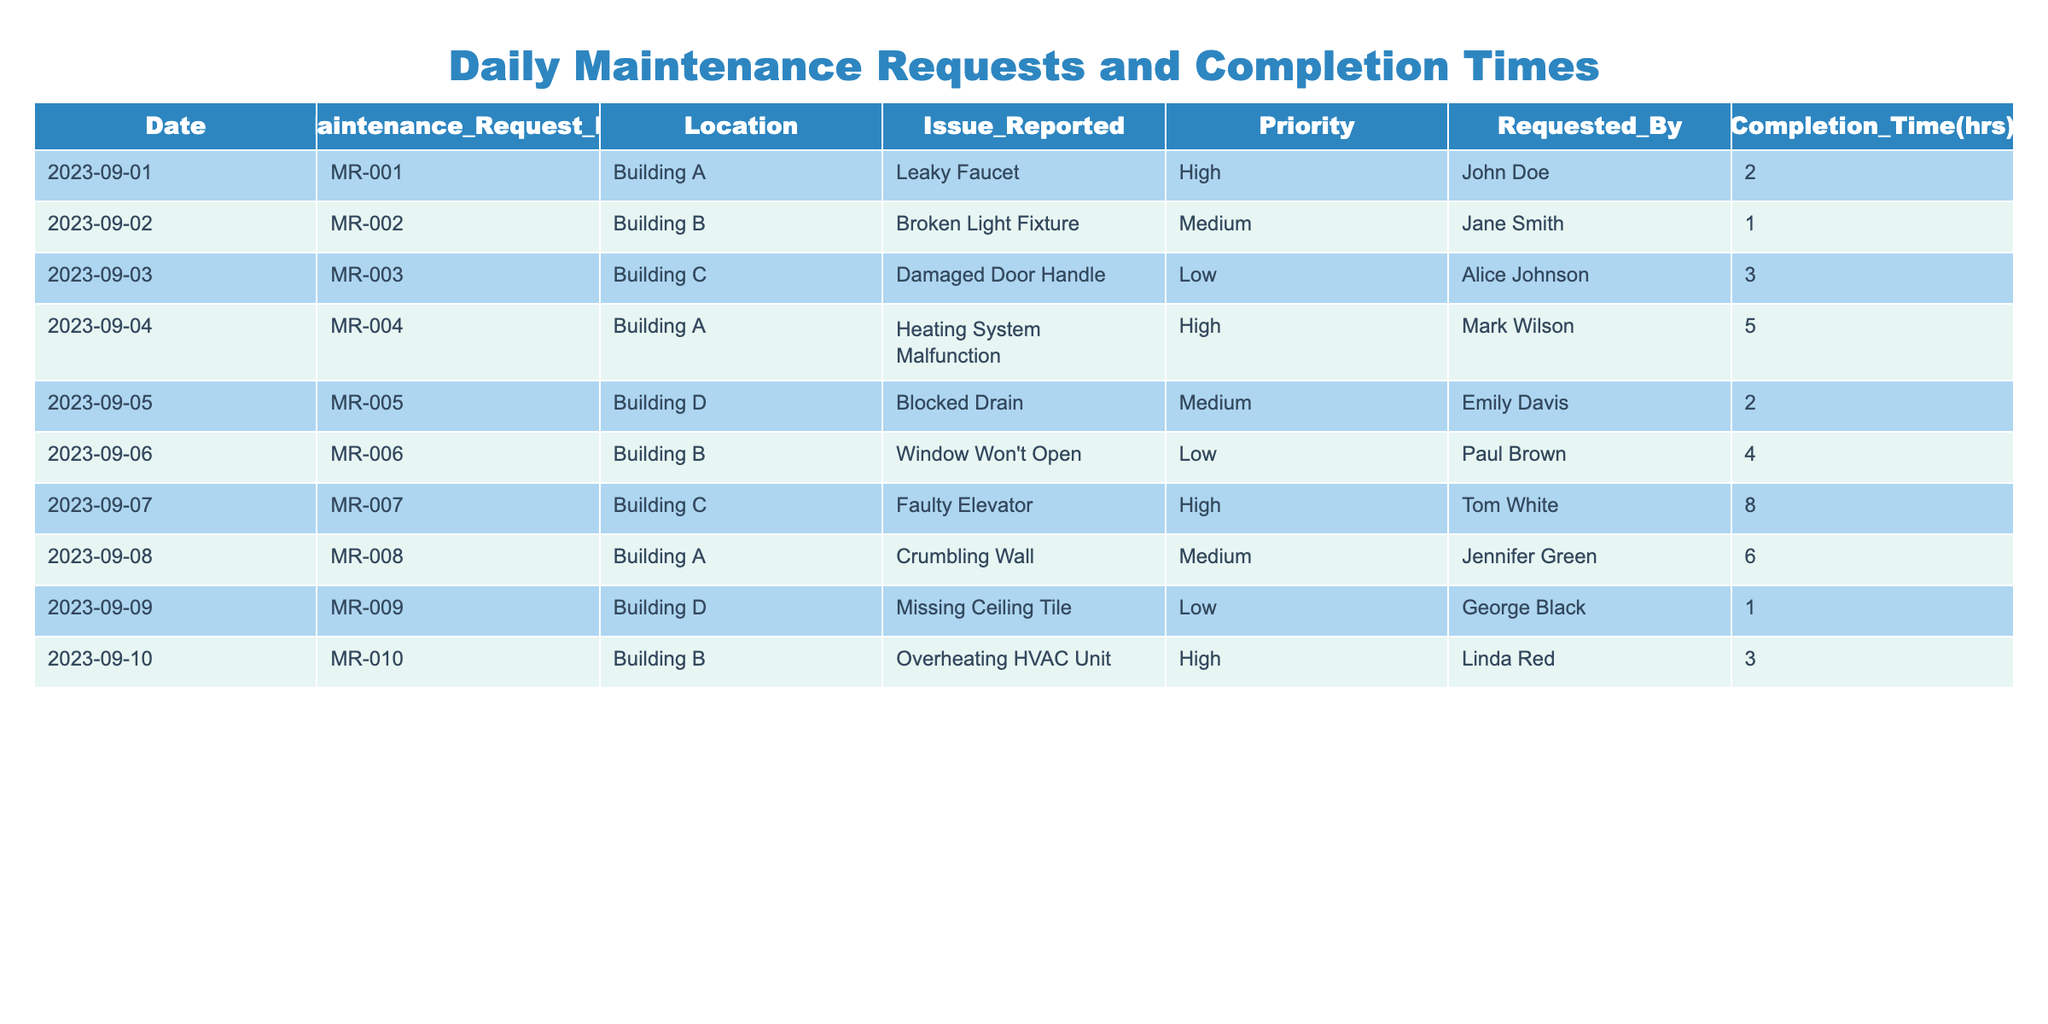What is the highest completion time recorded in the table? The highest completion time is found by scanning the Completion Time column for the maximum value. The values are 2, 1, 3, 5, 2, 4, 8, 6, 1, and 3. The maximum is 8, which corresponds to the Faulty Elevator issue in Building C.
Answer: 8 Which maintenance request has the lowest priority? To find the lowest priority, I look at the Priority column. The requests are categorized as High, Medium, and Low. The issues reported are Damaged Door Handle, Window Won't Open, Missing Ceiling Tile, and more—all categorized as Low priority. Thus, Damaged Door Handle on 2023-09-03 has the lowest priority.
Answer: Damaged Door Handle What is the total completion time for all maintenance requests? We sum all the Completion Time values: 2 + 1 + 3 + 5 + 2 + 4 + 8 + 6 + 1 + 3 = 35 hours.
Answer: 35 Did any maintenance request take longer than 5 hours to complete? We need to check the Completion Time column for any values greater than 5. The values are 2, 1, 3, 5, 2, 4, 8, 6, 1, and 3. Since 8 and 6 are present, it shows that at least two requests took longer than 5 hours.
Answer: Yes What percentage of maintenance requests were considered high priority? First, we count the total number of requests: 10. Next, we count the number of high priority requests: MR-001, MR-004, MR-007, and MR-010, which totals to 4. To find the percentage, we calculate (4 / 10) * 100 = 40%.
Answer: 40% Which building had the highest number of maintenance issues reported? To determine the building with the most issues, we count the occurrences in the Location column. Building A appears 3 times, Building B appears 3 times, Building C appears 2 times, and Building D appears 2 times. Since both Building A and Building B tie for the highest number, they are equally the buildings with the most issues reported.
Answer: Building A and Building B What maintenance issue reported on September 4th had the longest completion time? On September 4th, only Heating System Malfunction in Building A is reported. Looking at the Completion Time, it took 5 hours, which is the only completion time for that date, making it effectively the longest.
Answer: Heating System Malfunction Is there any maintenance request completed by Paul Brown? We check the Requested By column for Paul Brown. There is one maintenance request reported on September 6th for the Window Won't Open. Since it appears, the answer is yes.
Answer: Yes 